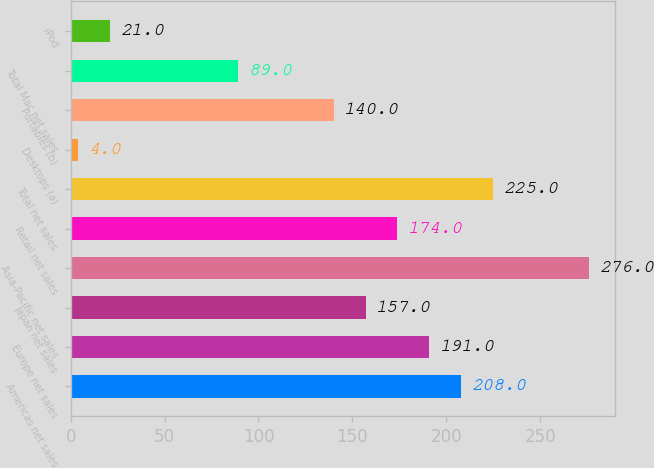<chart> <loc_0><loc_0><loc_500><loc_500><bar_chart><fcel>Americas net sales<fcel>Europe net sales<fcel>Japan net sales<fcel>Asia-Pacific net sales<fcel>Retail net sales<fcel>Total net sales<fcel>Desktops (a)<fcel>Portables (b)<fcel>Total Mac net sales<fcel>iPod<nl><fcel>208<fcel>191<fcel>157<fcel>276<fcel>174<fcel>225<fcel>4<fcel>140<fcel>89<fcel>21<nl></chart> 